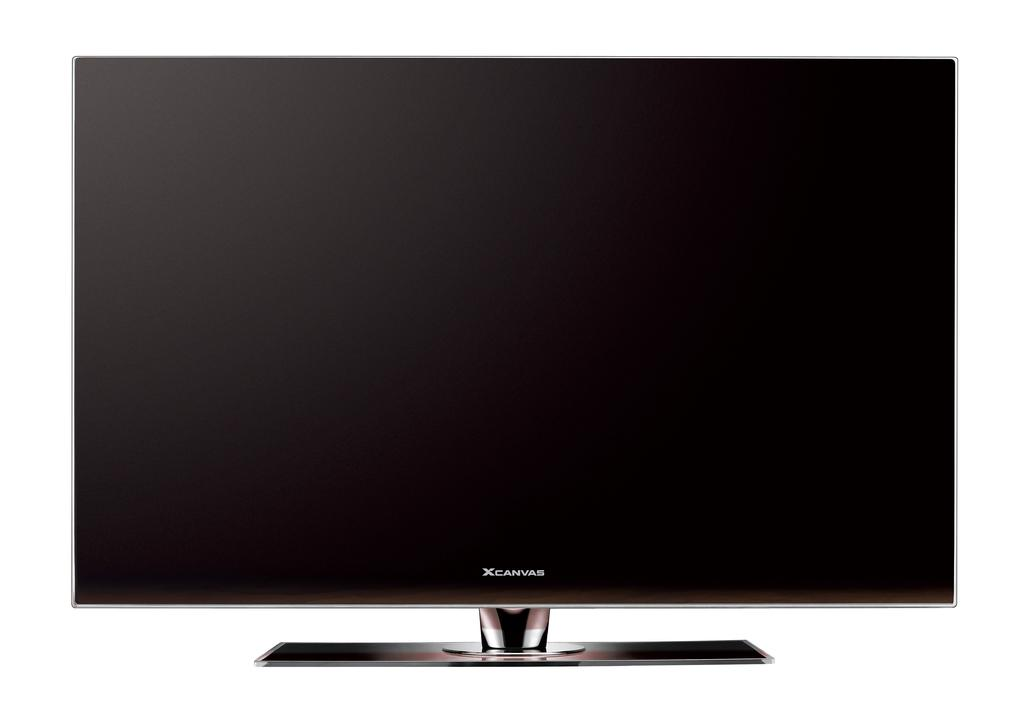<image>
Provide a brief description of the given image. A large flat screen TV that says XCanvas on it in front of a white background. 